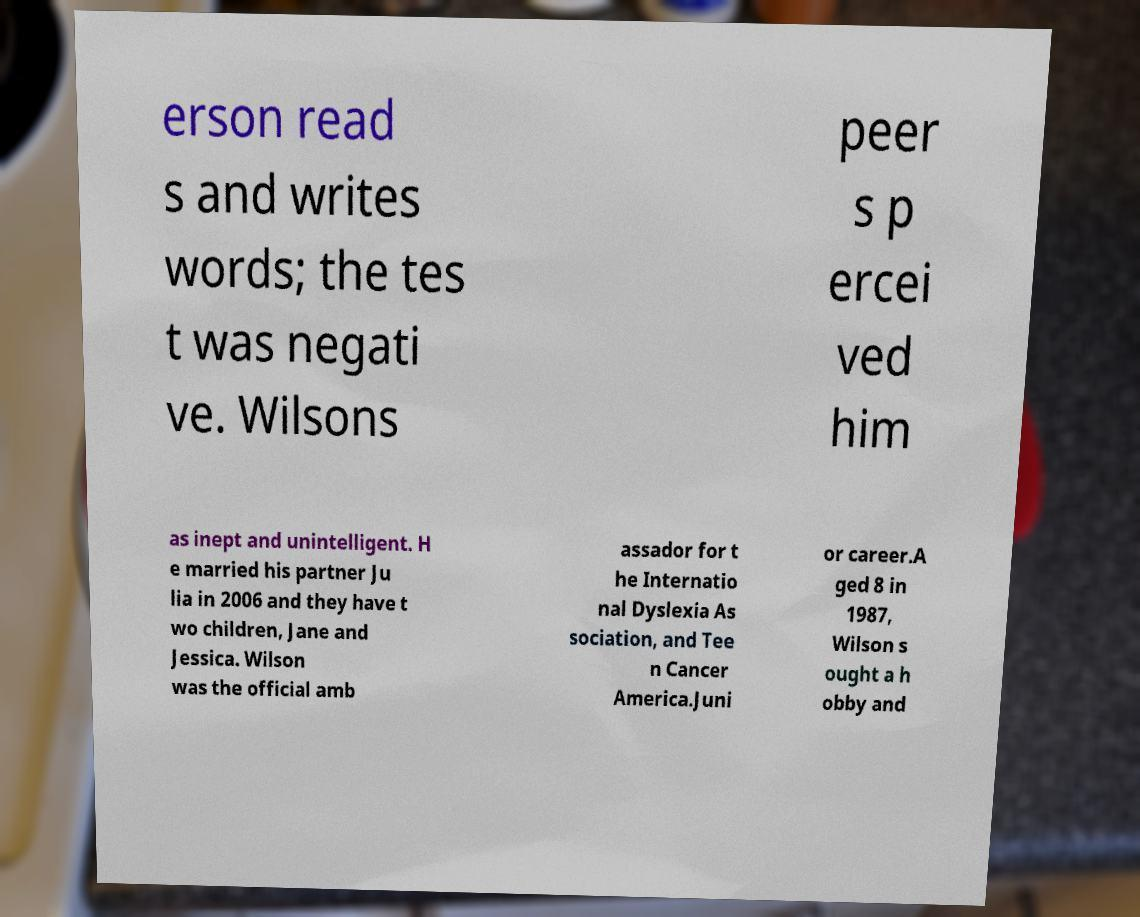Can you read and provide the text displayed in the image?This photo seems to have some interesting text. Can you extract and type it out for me? erson read s and writes words; the tes t was negati ve. Wilsons peer s p ercei ved him as inept and unintelligent. H e married his partner Ju lia in 2006 and they have t wo children, Jane and Jessica. Wilson was the official amb assador for t he Internatio nal Dyslexia As sociation, and Tee n Cancer America.Juni or career.A ged 8 in 1987, Wilson s ought a h obby and 